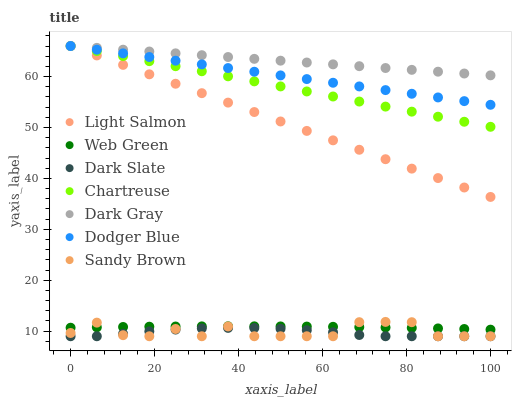Does Dark Slate have the minimum area under the curve?
Answer yes or no. Yes. Does Dark Gray have the maximum area under the curve?
Answer yes or no. Yes. Does Web Green have the minimum area under the curve?
Answer yes or no. No. Does Web Green have the maximum area under the curve?
Answer yes or no. No. Is Chartreuse the smoothest?
Answer yes or no. Yes. Is Sandy Brown the roughest?
Answer yes or no. Yes. Is Web Green the smoothest?
Answer yes or no. No. Is Web Green the roughest?
Answer yes or no. No. Does Dark Slate have the lowest value?
Answer yes or no. Yes. Does Web Green have the lowest value?
Answer yes or no. No. Does Dodger Blue have the highest value?
Answer yes or no. Yes. Does Web Green have the highest value?
Answer yes or no. No. Is Dark Slate less than Dark Gray?
Answer yes or no. Yes. Is Light Salmon greater than Sandy Brown?
Answer yes or no. Yes. Does Dark Gray intersect Light Salmon?
Answer yes or no. Yes. Is Dark Gray less than Light Salmon?
Answer yes or no. No. Is Dark Gray greater than Light Salmon?
Answer yes or no. No. Does Dark Slate intersect Dark Gray?
Answer yes or no. No. 